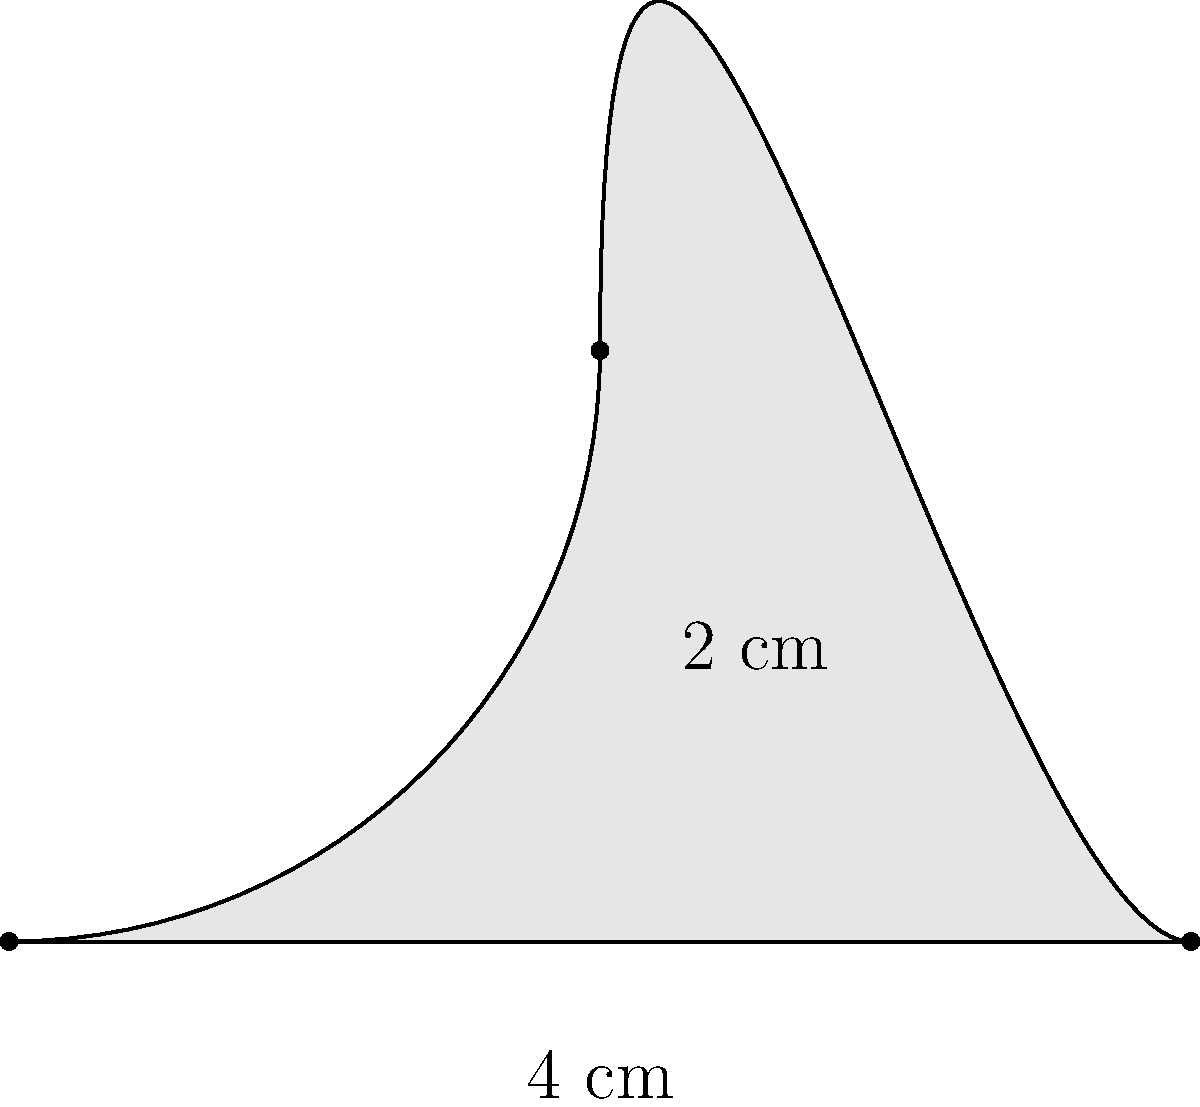As a wine enthusiast, you're designing a custom label for your favorite Cabernet Sauvignon. The label has a unique shape with curved edges, as shown in the diagram. The base of the label is 4 cm wide, and the height at its peak is 2 cm. Assuming the curve can be approximated as a parabola, calculate the area of this wine bottle label in square centimeters. To calculate the area of this wine bottle label, we'll use the formula for the area under a parabola:

1) The general formula for the area under a parabola is:
   $$A = \frac{2}{3} \times base \times height$$

2) We're given:
   base = 4 cm
   height = 2 cm

3) Plugging these values into our formula:
   $$A = \frac{2}{3} \times 4 \times 2$$

4) Simplifying:
   $$A = \frac{2}{3} \times 8 = \frac{16}{3}$$

5) Calculate the final result:
   $$A = 5.33 \text{ cm}^2$$ (rounded to two decimal places)

This method assumes that the curve is a perfect parabola. In reality, the shape might be slightly different, but this approximation gives us a good estimate of the label's area.
Answer: $5.33 \text{ cm}^2$ 